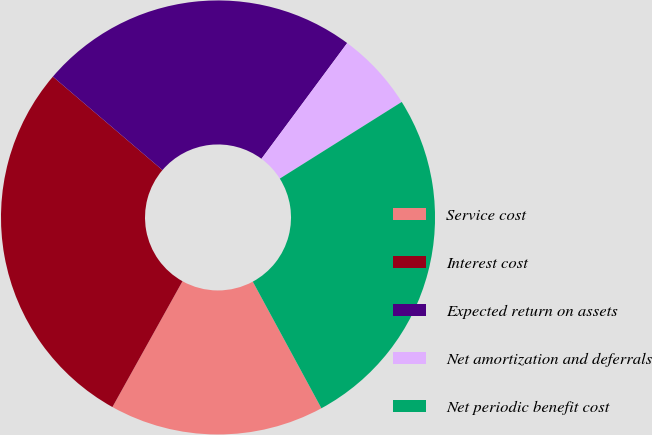Convert chart to OTSL. <chart><loc_0><loc_0><loc_500><loc_500><pie_chart><fcel>Service cost<fcel>Interest cost<fcel>Expected return on assets<fcel>Net amortization and deferrals<fcel>Net periodic benefit cost<nl><fcel>15.99%<fcel>28.15%<fcel>23.91%<fcel>5.92%<fcel>26.03%<nl></chart> 